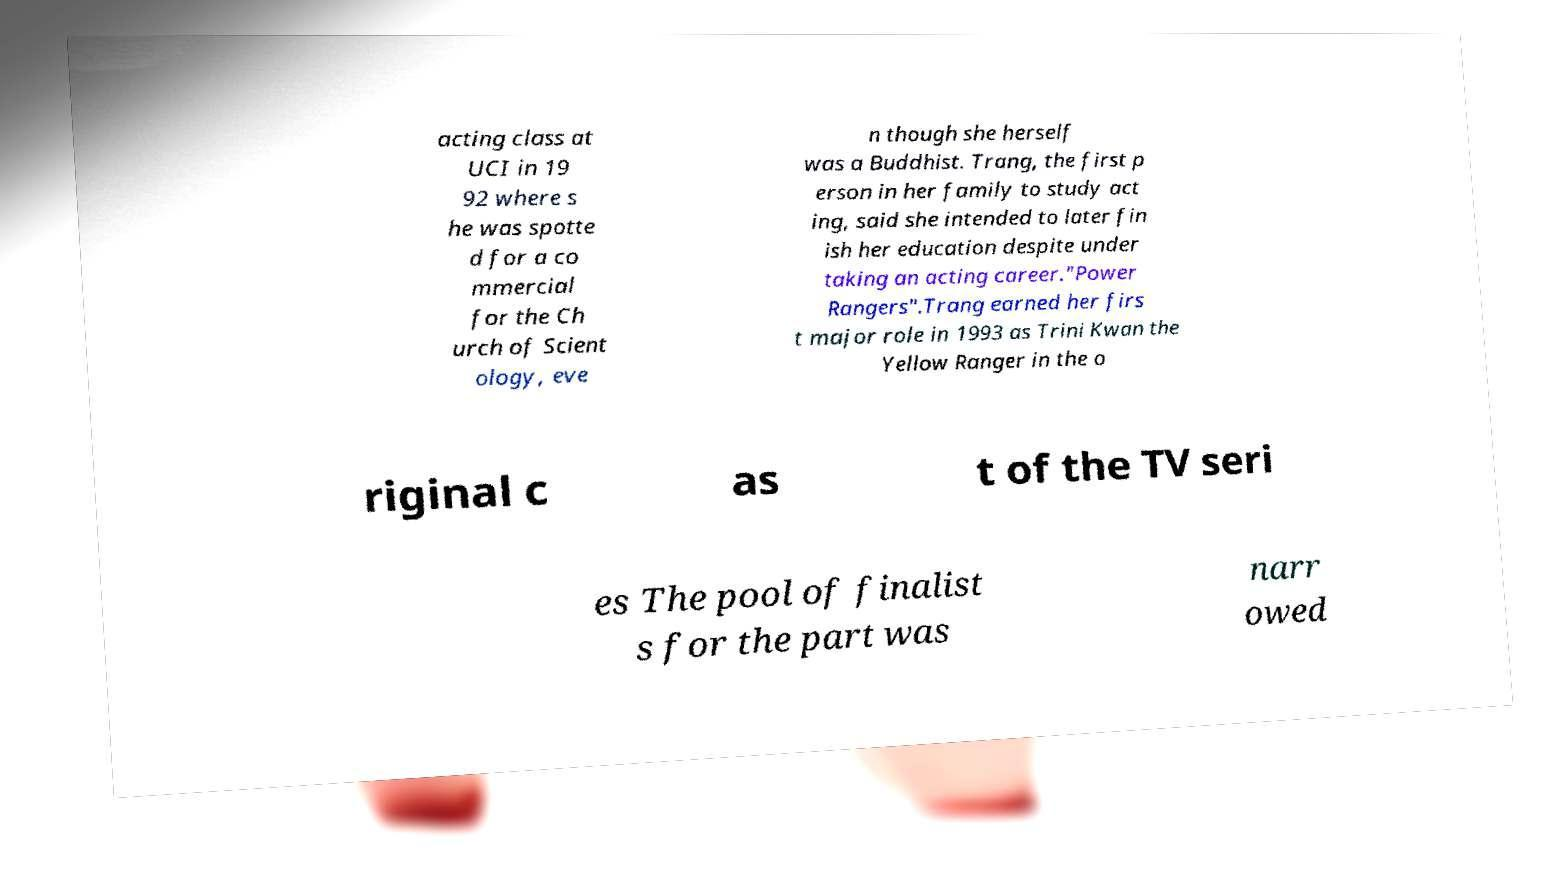Could you extract and type out the text from this image? acting class at UCI in 19 92 where s he was spotte d for a co mmercial for the Ch urch of Scient ology, eve n though she herself was a Buddhist. Trang, the first p erson in her family to study act ing, said she intended to later fin ish her education despite under taking an acting career."Power Rangers".Trang earned her firs t major role in 1993 as Trini Kwan the Yellow Ranger in the o riginal c as t of the TV seri es The pool of finalist s for the part was narr owed 